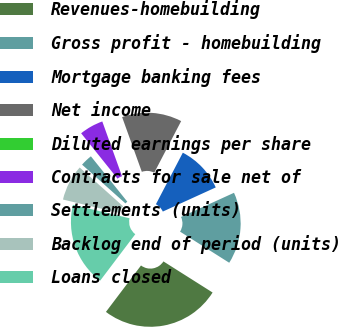Convert chart. <chart><loc_0><loc_0><loc_500><loc_500><pie_chart><fcel>Revenues-homebuilding<fcel>Gross profit - homebuilding<fcel>Mortgage banking fees<fcel>Net income<fcel>Diluted earnings per share<fcel>Contracts for sale net of<fcel>Settlements (units)<fcel>Backlog end of period (units)<fcel>Loans closed<nl><fcel>26.32%<fcel>15.79%<fcel>10.53%<fcel>13.16%<fcel>0.0%<fcel>5.26%<fcel>2.63%<fcel>7.89%<fcel>18.42%<nl></chart> 